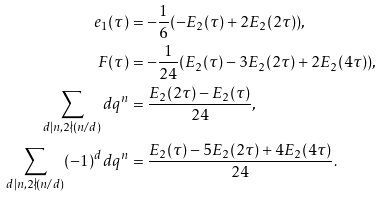<formula> <loc_0><loc_0><loc_500><loc_500>e _ { 1 } ( \tau ) & = - \frac { 1 } { 6 } ( - E _ { 2 } ( \tau ) + 2 E _ { 2 } ( 2 \tau ) ) , \\ F ( \tau ) & = - \frac { 1 } { 2 4 } ( E _ { 2 } ( \tau ) - 3 E _ { 2 } ( 2 \tau ) + 2 E _ { 2 } ( 4 \tau ) ) , \\ \sum _ { d | n , 2 \nmid ( n / d ) } d q ^ { n } & = \frac { E _ { 2 } ( 2 \tau ) - E _ { 2 } ( \tau ) } { 2 4 } , \\ \sum _ { d | n , 2 \nmid ( n / d ) } ( - 1 ) ^ { d } d q ^ { n } & = \frac { E _ { 2 } ( \tau ) - 5 E _ { 2 } ( 2 \tau ) + 4 E _ { 2 } ( 4 \tau ) } { 2 4 } .</formula> 